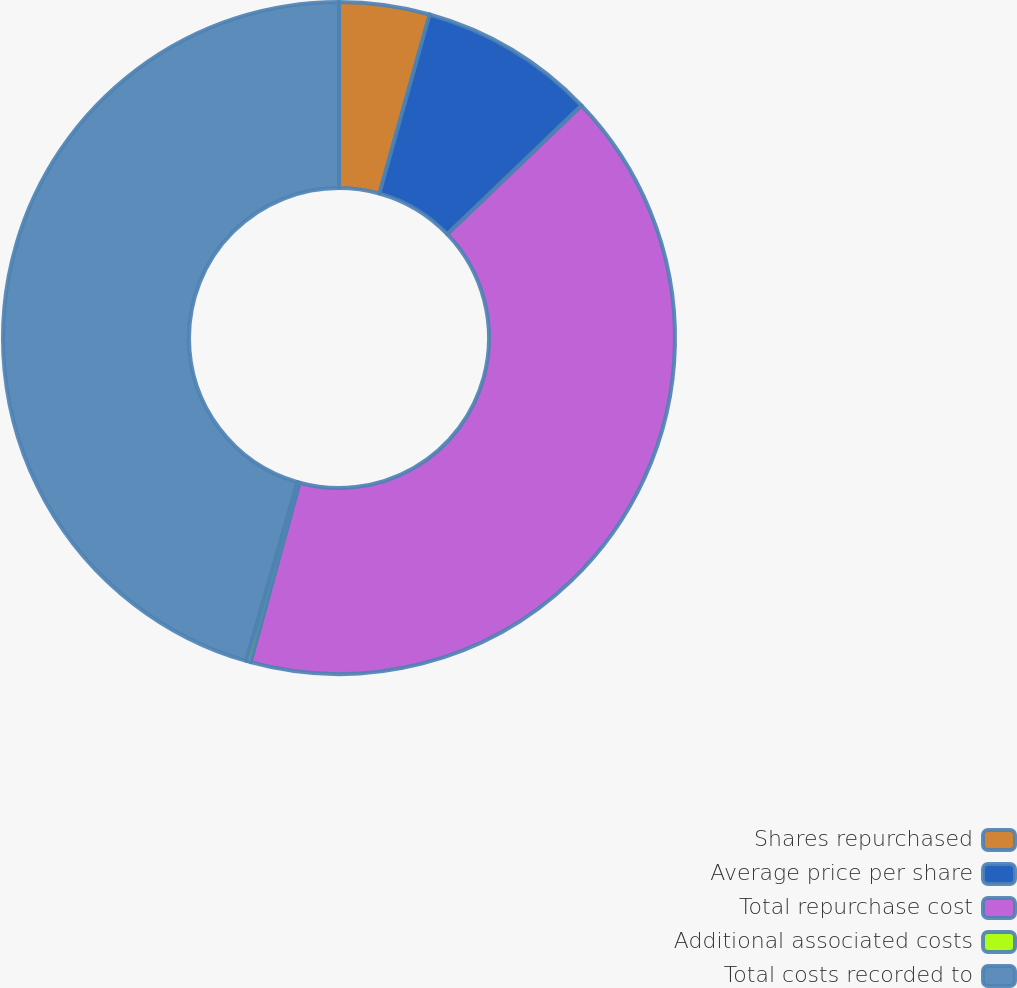Convert chart to OTSL. <chart><loc_0><loc_0><loc_500><loc_500><pie_chart><fcel>Shares repurchased<fcel>Average price per share<fcel>Total repurchase cost<fcel>Additional associated costs<fcel>Total costs recorded to<nl><fcel>4.35%<fcel>8.49%<fcel>41.41%<fcel>0.21%<fcel>45.55%<nl></chart> 